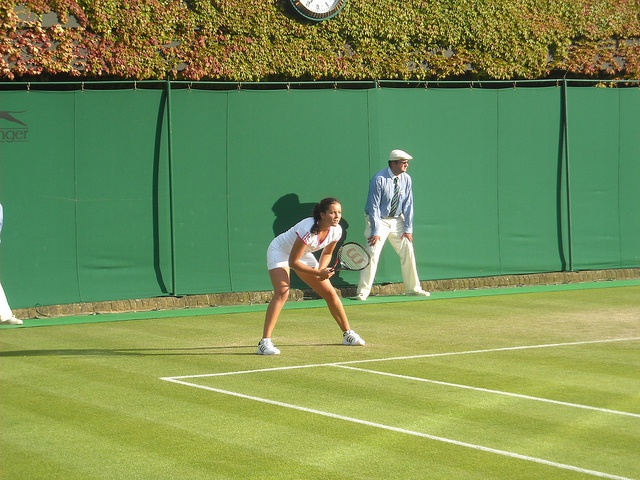Describe the objects in this image and their specific colors. I can see people in khaki, maroon, white, darkgray, and tan tones, people in khaki, white, darkgray, gray, and beige tones, clock in khaki, white, black, gray, and darkgreen tones, tennis racket in khaki, darkgray, gray, and black tones, and people in khaki, white, green, tan, and beige tones in this image. 